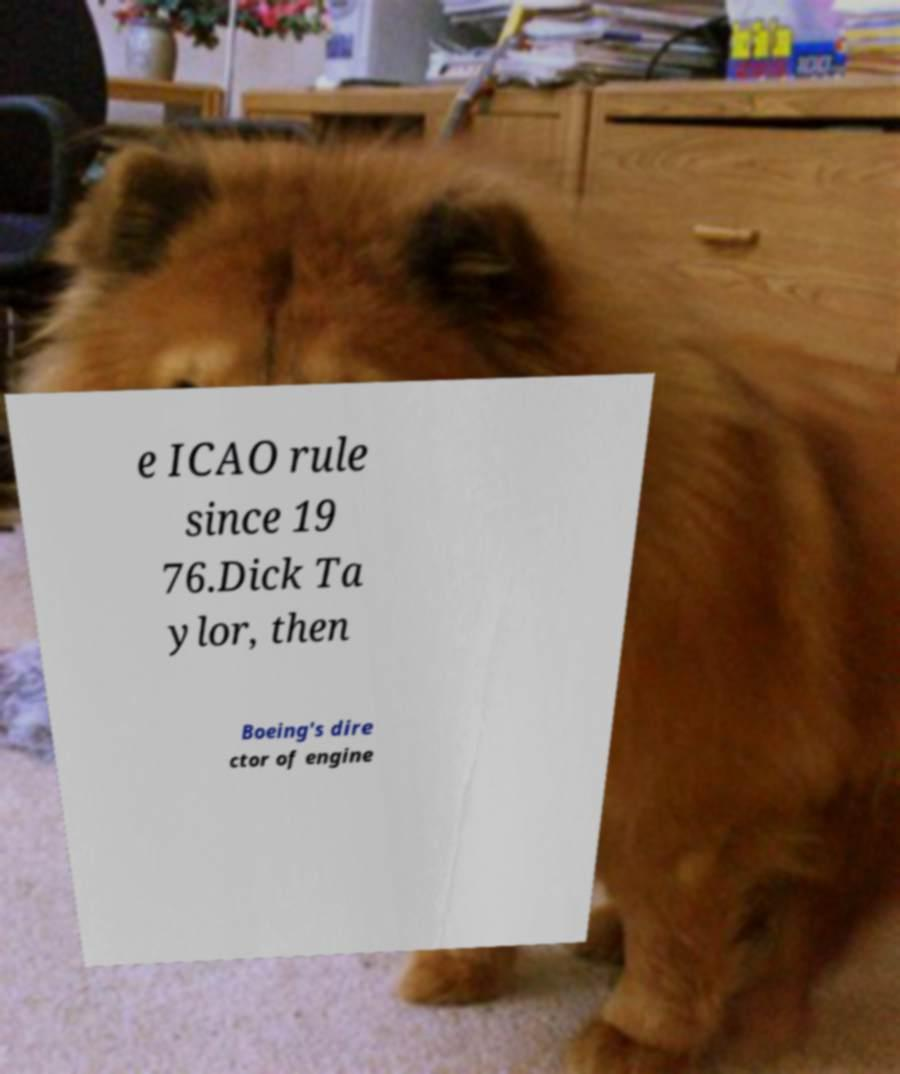For documentation purposes, I need the text within this image transcribed. Could you provide that? e ICAO rule since 19 76.Dick Ta ylor, then Boeing's dire ctor of engine 